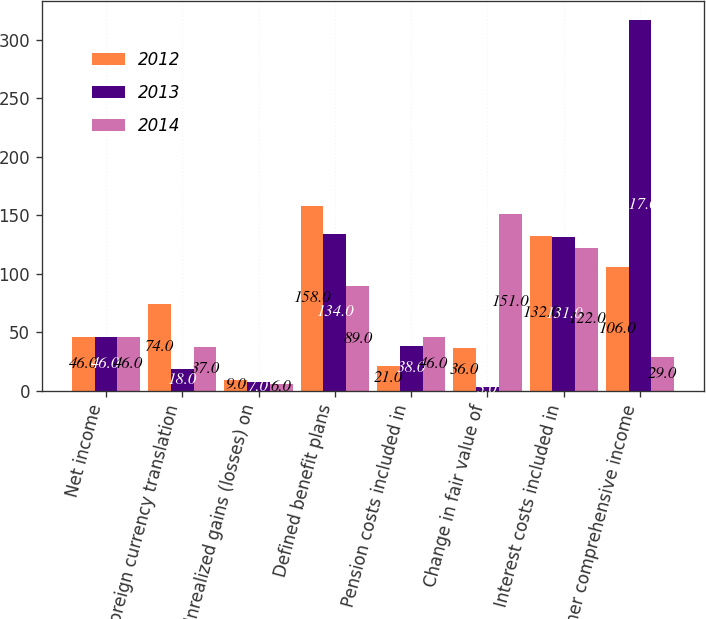<chart> <loc_0><loc_0><loc_500><loc_500><stacked_bar_chart><ecel><fcel>Net income<fcel>Foreign currency translation<fcel>Unrealized gains (losses) on<fcel>Defined benefit plans<fcel>Pension costs included in<fcel>Change in fair value of<fcel>Interest costs included in<fcel>Other comprehensive income<nl><fcel>2012<fcel>46<fcel>74<fcel>9<fcel>158<fcel>21<fcel>36<fcel>132<fcel>106<nl><fcel>2013<fcel>46<fcel>18<fcel>7<fcel>134<fcel>38<fcel>3<fcel>131<fcel>317<nl><fcel>2014<fcel>46<fcel>37<fcel>6<fcel>89<fcel>46<fcel>151<fcel>122<fcel>29<nl></chart> 